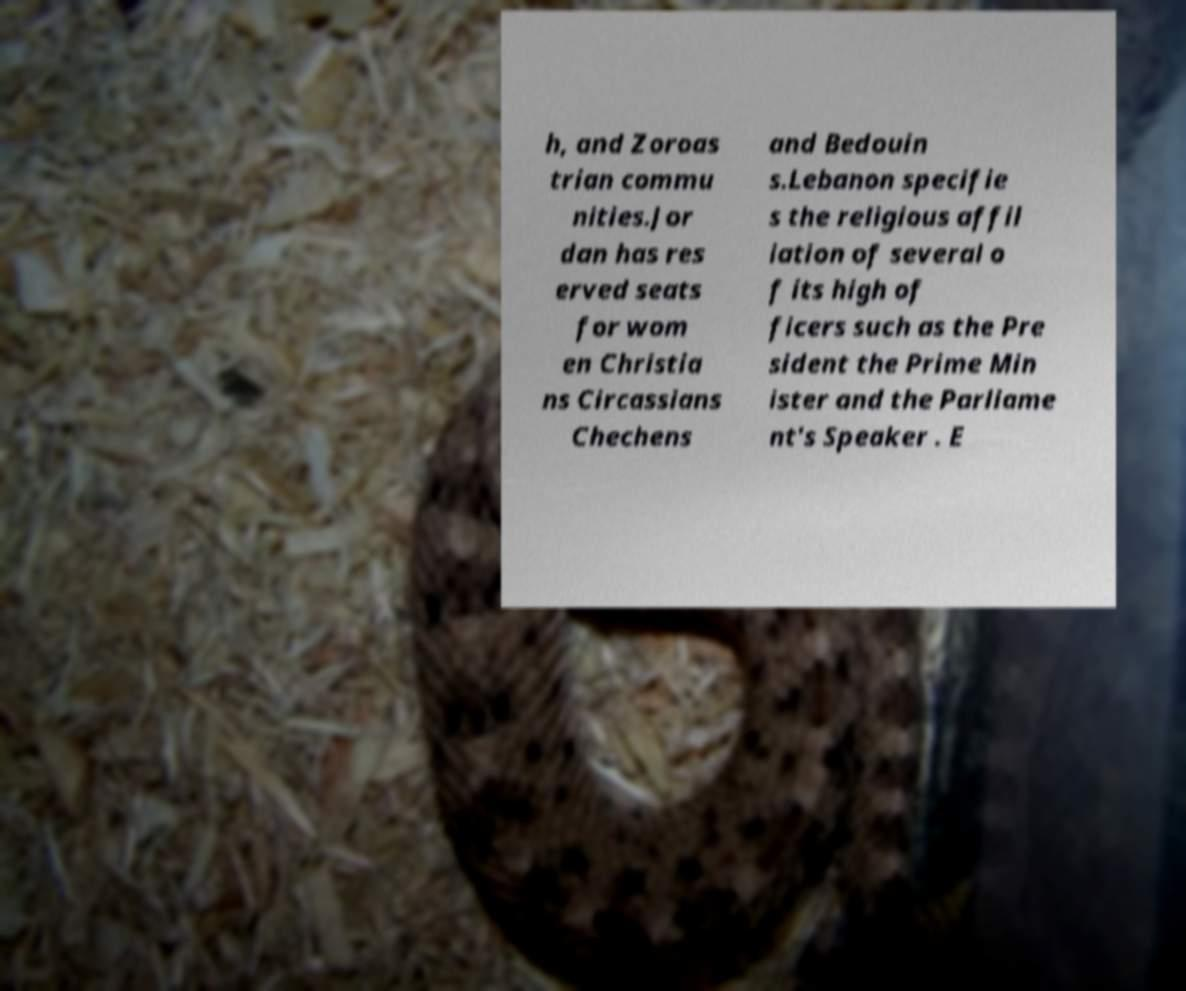I need the written content from this picture converted into text. Can you do that? h, and Zoroas trian commu nities.Jor dan has res erved seats for wom en Christia ns Circassians Chechens and Bedouin s.Lebanon specifie s the religious affil iation of several o f its high of ficers such as the Pre sident the Prime Min ister and the Parliame nt's Speaker . E 